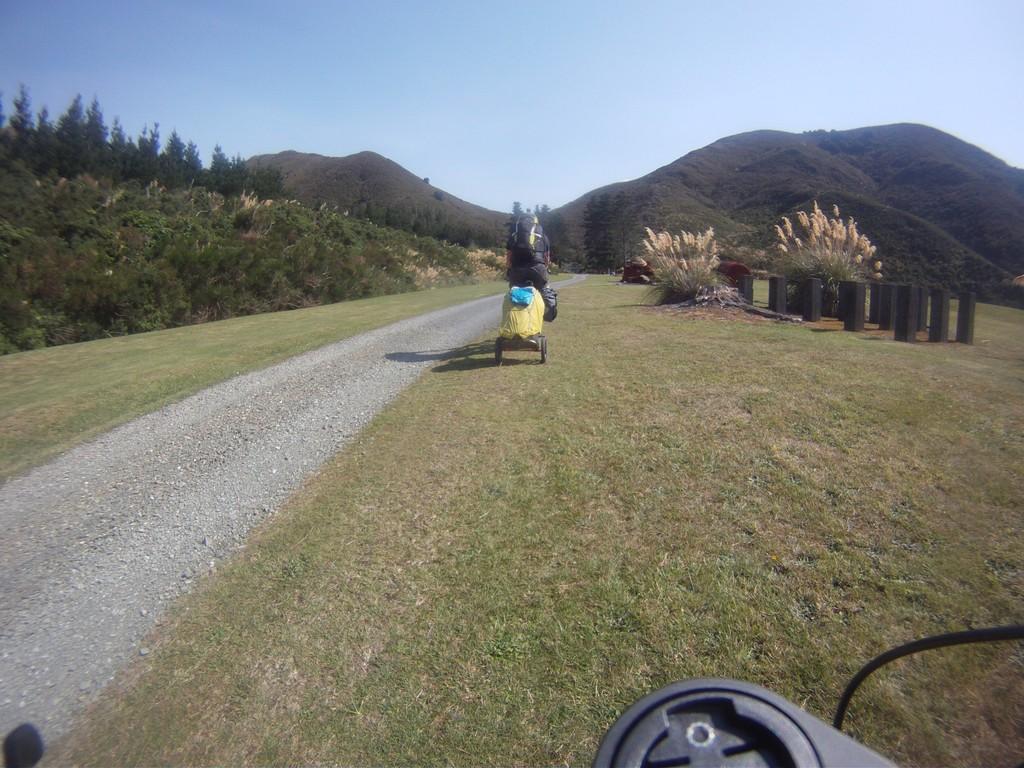Please provide a concise description of this image. In this picture we can see an object, here we can see a person on a vehicle on the ground, trees and some objects and in the background we can see mountains, sky. 